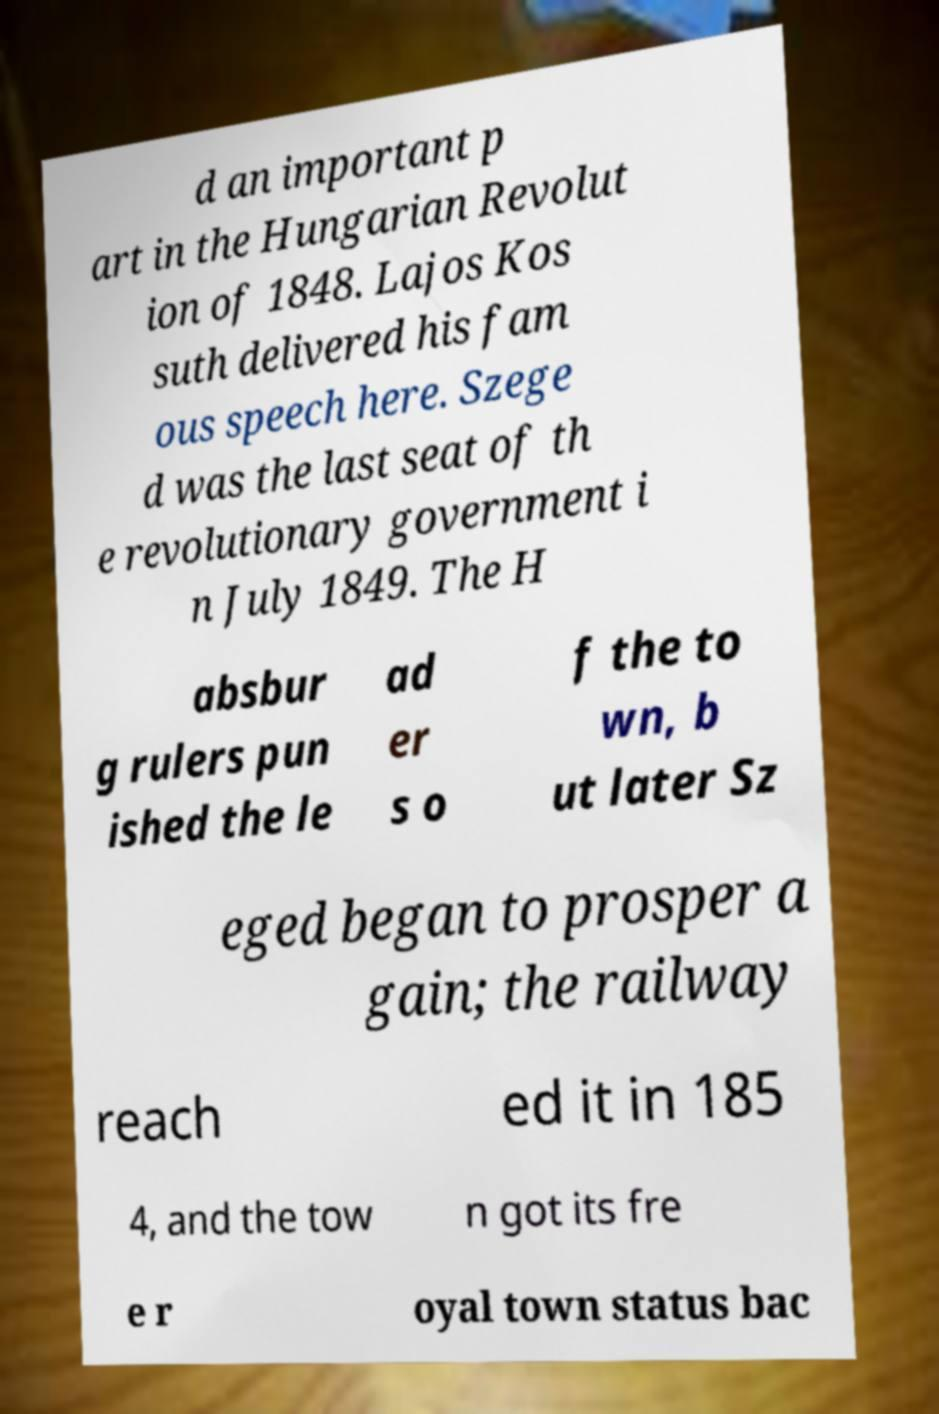Please identify and transcribe the text found in this image. d an important p art in the Hungarian Revolut ion of 1848. Lajos Kos suth delivered his fam ous speech here. Szege d was the last seat of th e revolutionary government i n July 1849. The H absbur g rulers pun ished the le ad er s o f the to wn, b ut later Sz eged began to prosper a gain; the railway reach ed it in 185 4, and the tow n got its fre e r oyal town status bac 